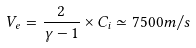<formula> <loc_0><loc_0><loc_500><loc_500>V _ { e } = \frac { 2 } { \gamma - 1 } \times C _ { i } \simeq 7 5 0 0 m / s</formula> 